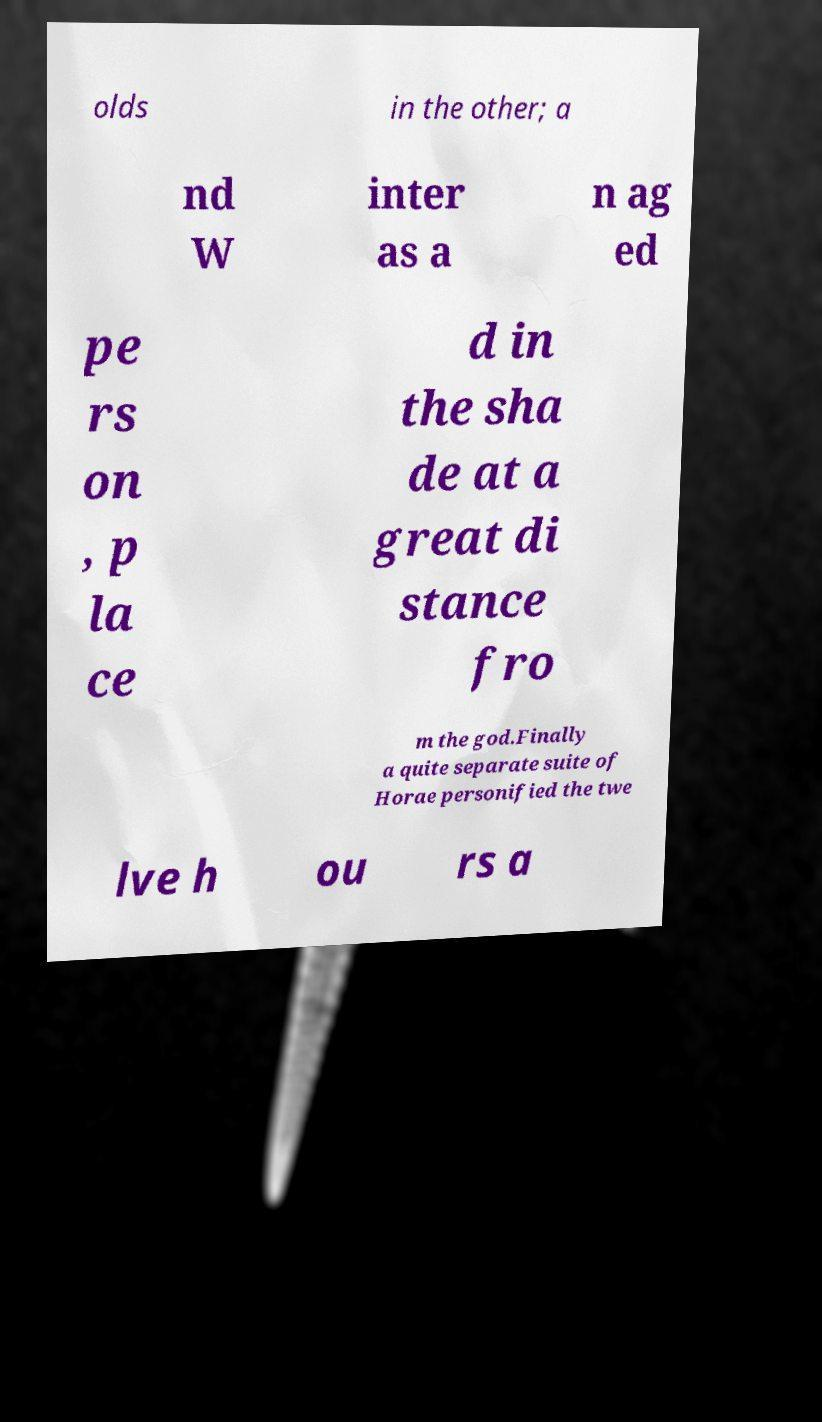There's text embedded in this image that I need extracted. Can you transcribe it verbatim? olds in the other; a nd W inter as a n ag ed pe rs on , p la ce d in the sha de at a great di stance fro m the god.Finally a quite separate suite of Horae personified the twe lve h ou rs a 